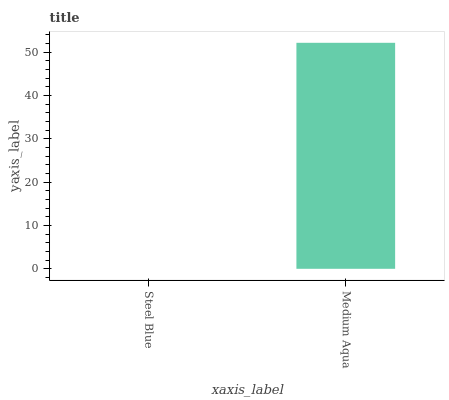Is Steel Blue the minimum?
Answer yes or no. Yes. Is Medium Aqua the maximum?
Answer yes or no. Yes. Is Medium Aqua the minimum?
Answer yes or no. No. Is Medium Aqua greater than Steel Blue?
Answer yes or no. Yes. Is Steel Blue less than Medium Aqua?
Answer yes or no. Yes. Is Steel Blue greater than Medium Aqua?
Answer yes or no. No. Is Medium Aqua less than Steel Blue?
Answer yes or no. No. Is Medium Aqua the high median?
Answer yes or no. Yes. Is Steel Blue the low median?
Answer yes or no. Yes. Is Steel Blue the high median?
Answer yes or no. No. Is Medium Aqua the low median?
Answer yes or no. No. 